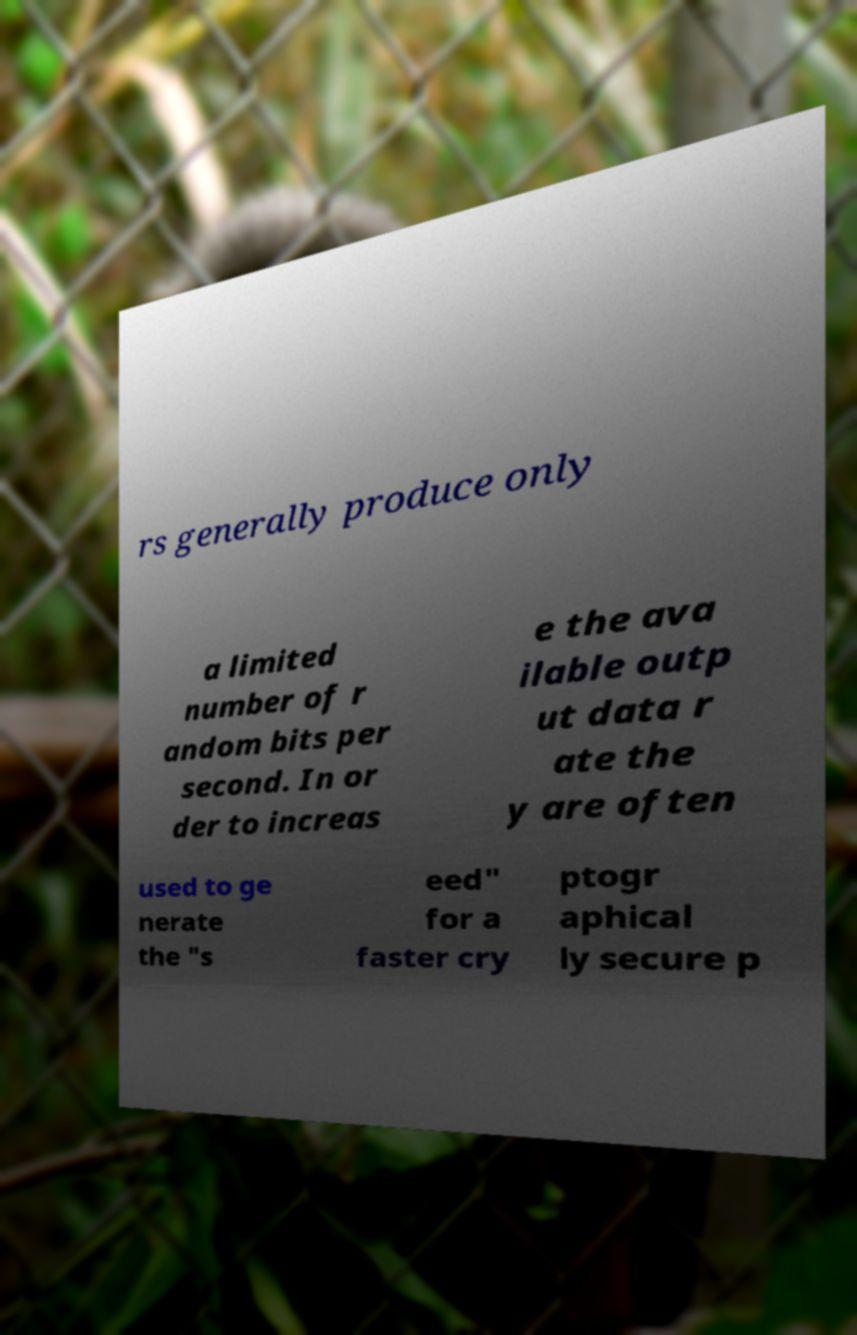For documentation purposes, I need the text within this image transcribed. Could you provide that? rs generally produce only a limited number of r andom bits per second. In or der to increas e the ava ilable outp ut data r ate the y are often used to ge nerate the "s eed" for a faster cry ptogr aphical ly secure p 